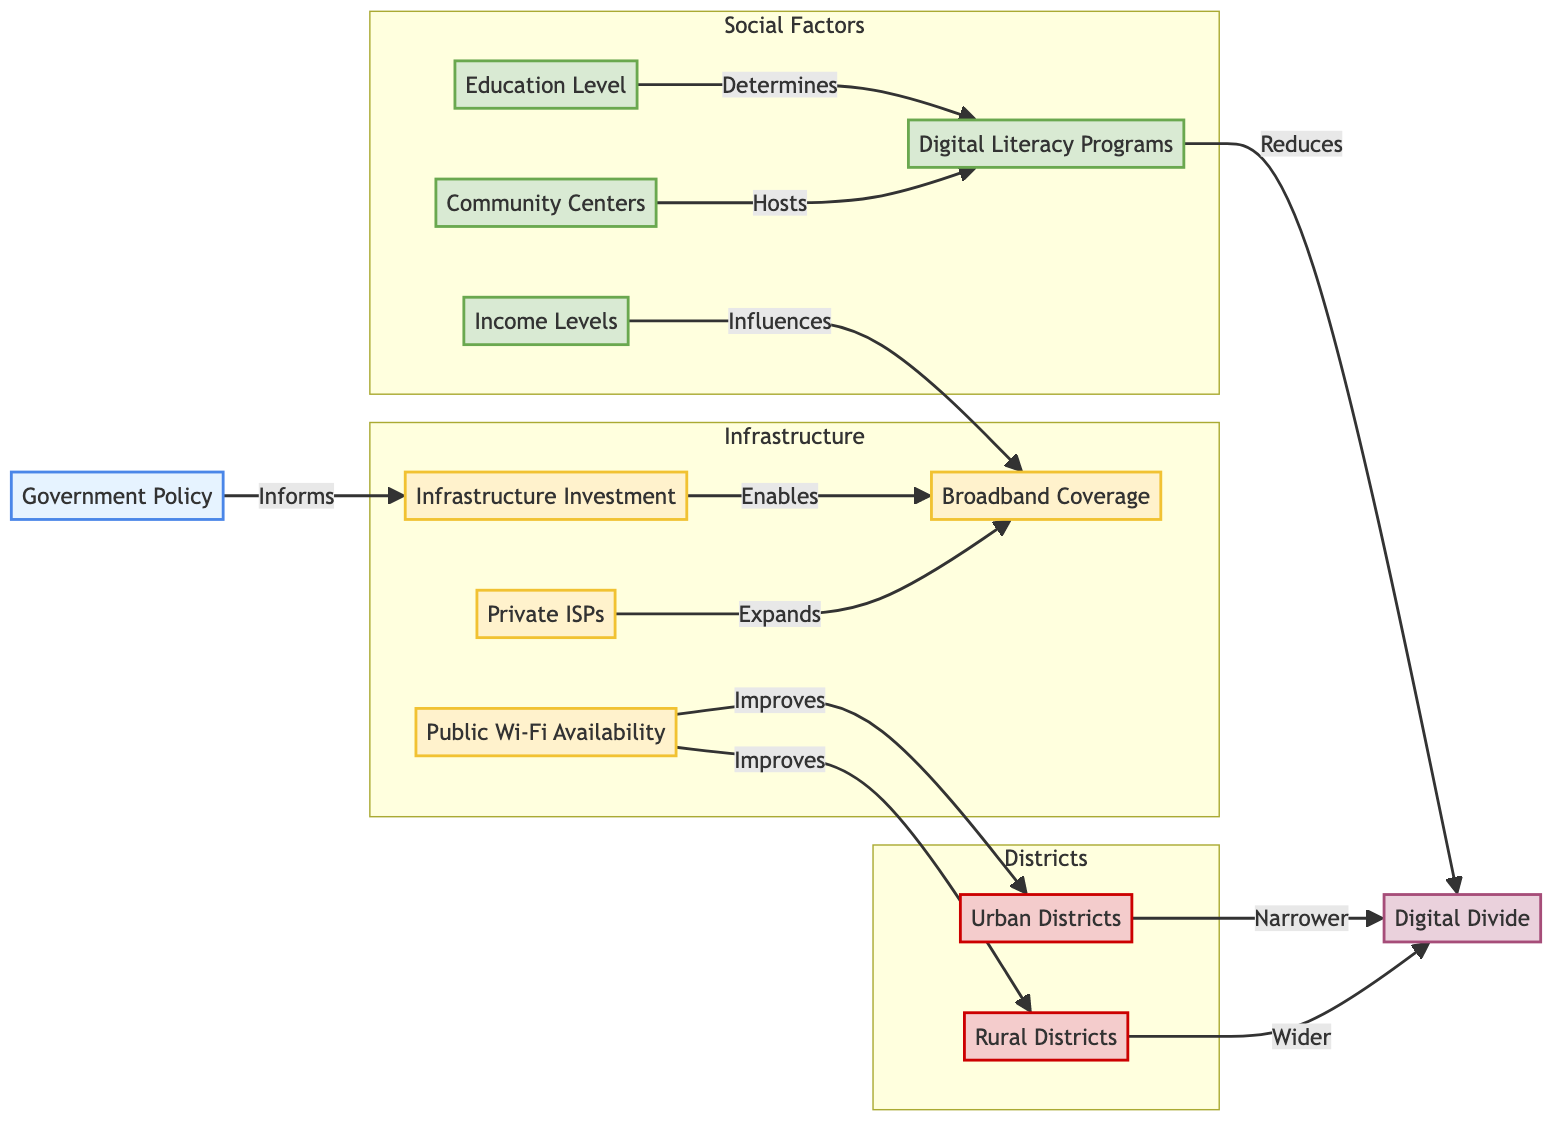What is the primary factor that informs infrastructure investment? According to the diagram, Government Policy is the primary factor that informs Infrastructure Investment, as indicated by the directed arrow from GP (Government Policy) to II (Infrastructure Investment).
Answer: Government Policy Which two types of districts have a different impact on the digital divide? The diagram shows that Urban Districts (UD) lead to a narrower Digital Divide (DD), while Rural Districts (RD) contribute to a wider Digital Divide. This relationship is demonstrated by the different arrows pointing from UD and RD to DD.
Answer: Urban and Rural Districts What role do digital literacy programs play in addressing the digital divide? The diagram indicates that Digital Literacy Programs (DLP) reduce the Digital Divide (DD), as shown by the arrow that connects DLP to DD. This signifies a positive impact of DLP on the level of access and participation in the digital space.
Answer: Reduces How many components are in the Infrastructure subgraph? The Infrastructure subgraph consists of four components which include Infrastructure Investment (II), Broadband Coverage (BC), Public Wi-Fi Availability (PW), and Private ISPs (PI), as identified within the subgraph.
Answer: Four components Which social factor primarily determines the implementation of digital literacy programs? Education Level (EL) is identified in the diagram as the factor that determines Digital Literacy Programs (DLP), illustrated by the arrow leading from EL to DLP. This indicates that higher education levels influence the establishment of these programs.
Answer: Education Level How do public Wi-Fi availability and private ISPs contribute to broadband coverage? The diagram shows that both Public Wi-Fi Availability (PW) and Private ISPs (PI) expand Broadband Coverage (BC) as indicated by the directed arrows leading towards BC from both PW and PI. This suggests that both factors are crucial for improving broadband access.
Answer: Expand What is the relationship between income levels and broadband coverage? The relationship depicted in the diagram shows that Income Levels (IL) influence Broadband Coverage (BC), indicated by the directed arrow from IL to BC. This means that areas with higher income levels tend to have better broadband coverage.
Answer: Influences Which component hosts digital literacy programs? Community Centers (CC) are identified in the diagram as the component that hosts Digital Literacy Programs (DLP), represented by the arrow connecting CC to DLP. This illustrates how community engagement can facilitate digital learning initiatives.
Answer: Community Centers 